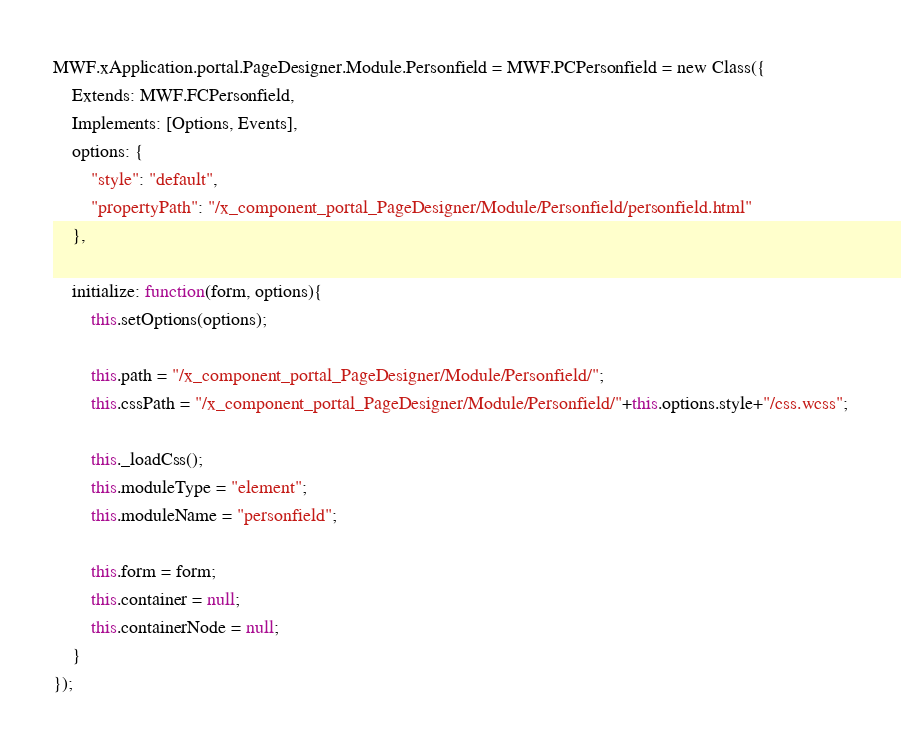<code> <loc_0><loc_0><loc_500><loc_500><_JavaScript_>MWF.xApplication.portal.PageDesigner.Module.Personfield = MWF.PCPersonfield = new Class({
	Extends: MWF.FCPersonfield,
	Implements: [Options, Events],
	options: {
		"style": "default",
		"propertyPath": "/x_component_portal_PageDesigner/Module/Personfield/personfield.html"
	},
	
	initialize: function(form, options){
		this.setOptions(options);
		
		this.path = "/x_component_portal_PageDesigner/Module/Personfield/";
		this.cssPath = "/x_component_portal_PageDesigner/Module/Personfield/"+this.options.style+"/css.wcss";

		this._loadCss();
		this.moduleType = "element";
		this.moduleName = "personfield";
		
		this.form = form;
		this.container = null;
		this.containerNode = null;
	}
});
</code> 